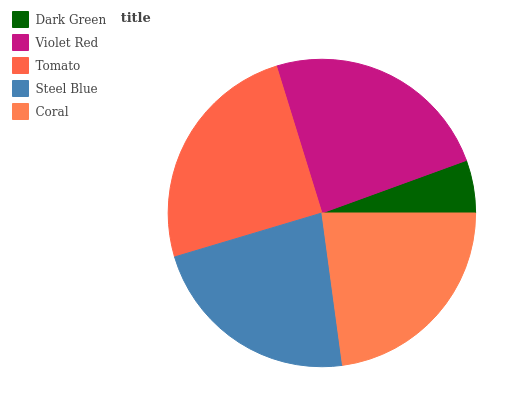Is Dark Green the minimum?
Answer yes or no. Yes. Is Tomato the maximum?
Answer yes or no. Yes. Is Violet Red the minimum?
Answer yes or no. No. Is Violet Red the maximum?
Answer yes or no. No. Is Violet Red greater than Dark Green?
Answer yes or no. Yes. Is Dark Green less than Violet Red?
Answer yes or no. Yes. Is Dark Green greater than Violet Red?
Answer yes or no. No. Is Violet Red less than Dark Green?
Answer yes or no. No. Is Coral the high median?
Answer yes or no. Yes. Is Coral the low median?
Answer yes or no. Yes. Is Tomato the high median?
Answer yes or no. No. Is Dark Green the low median?
Answer yes or no. No. 